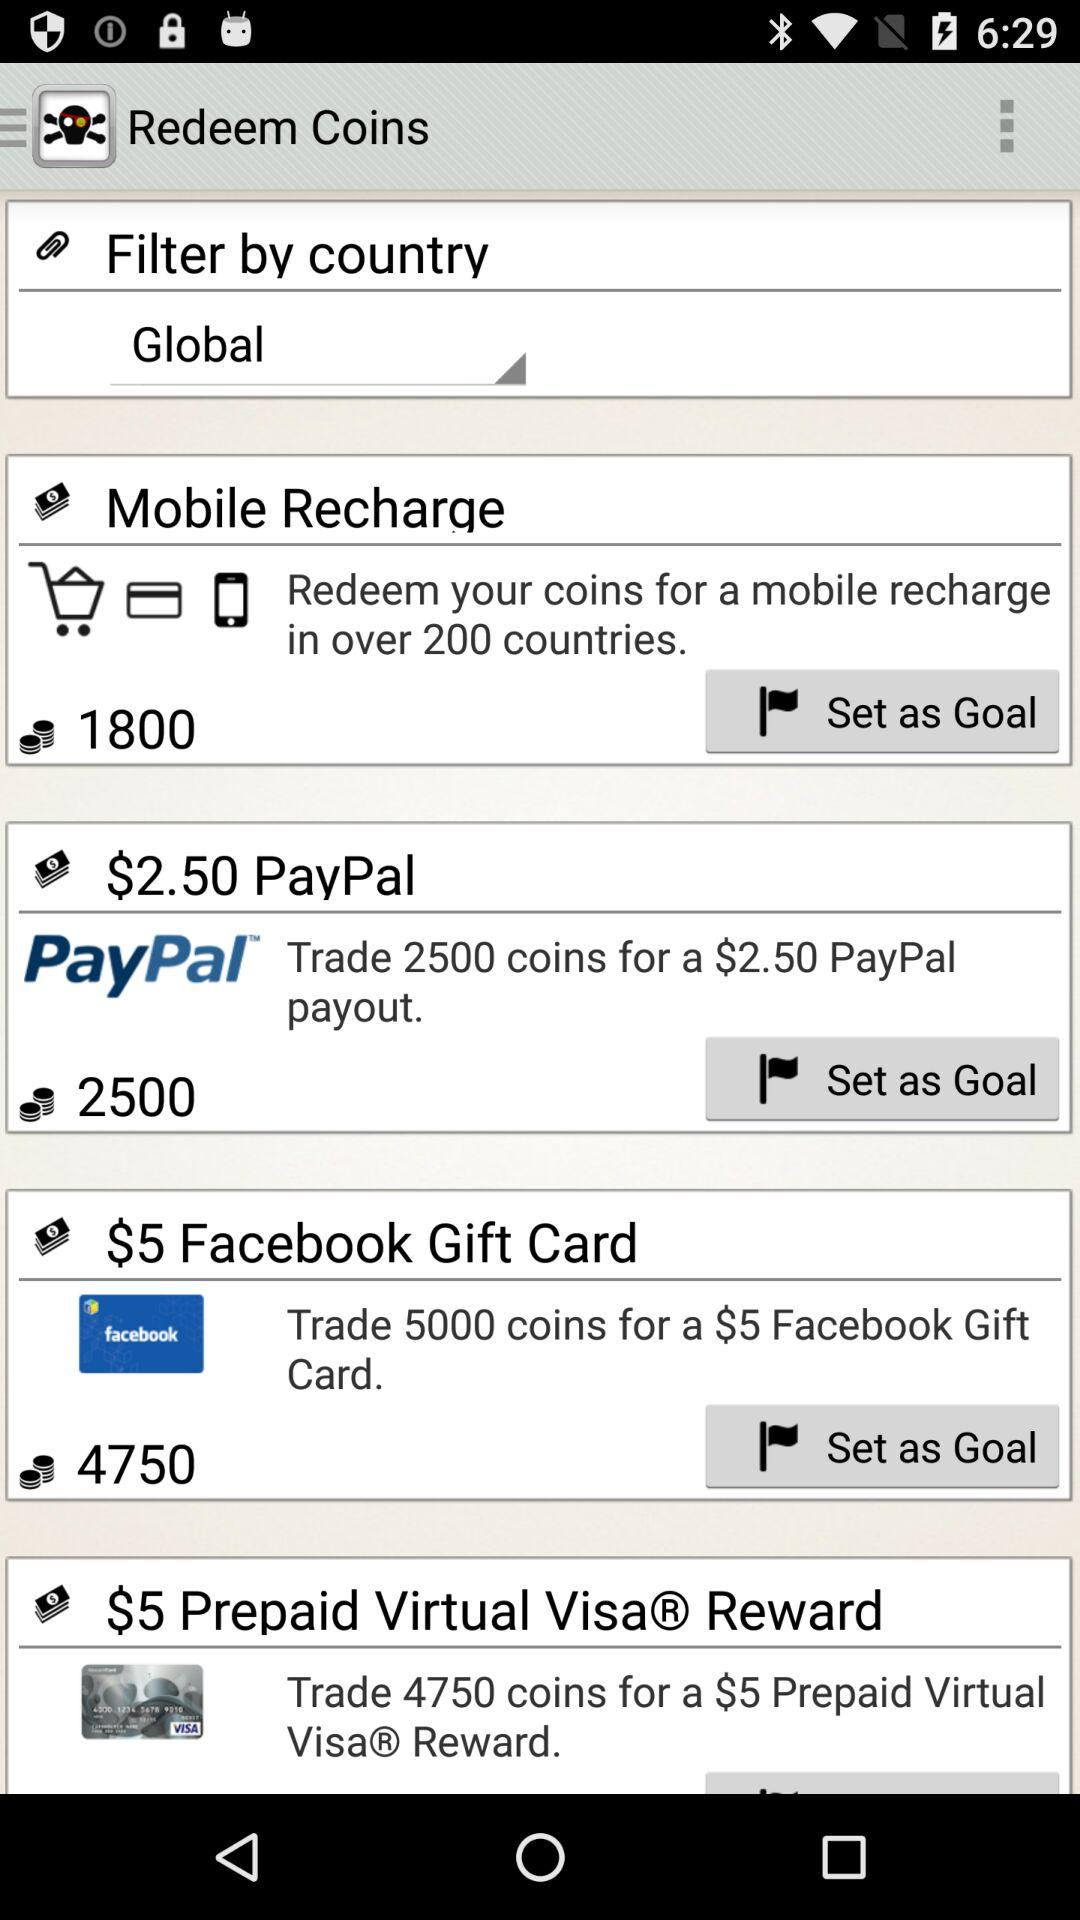For how many coins can we get a Facebook Gift Card? You can get a Facebook Gift Card for 5000 coins. 